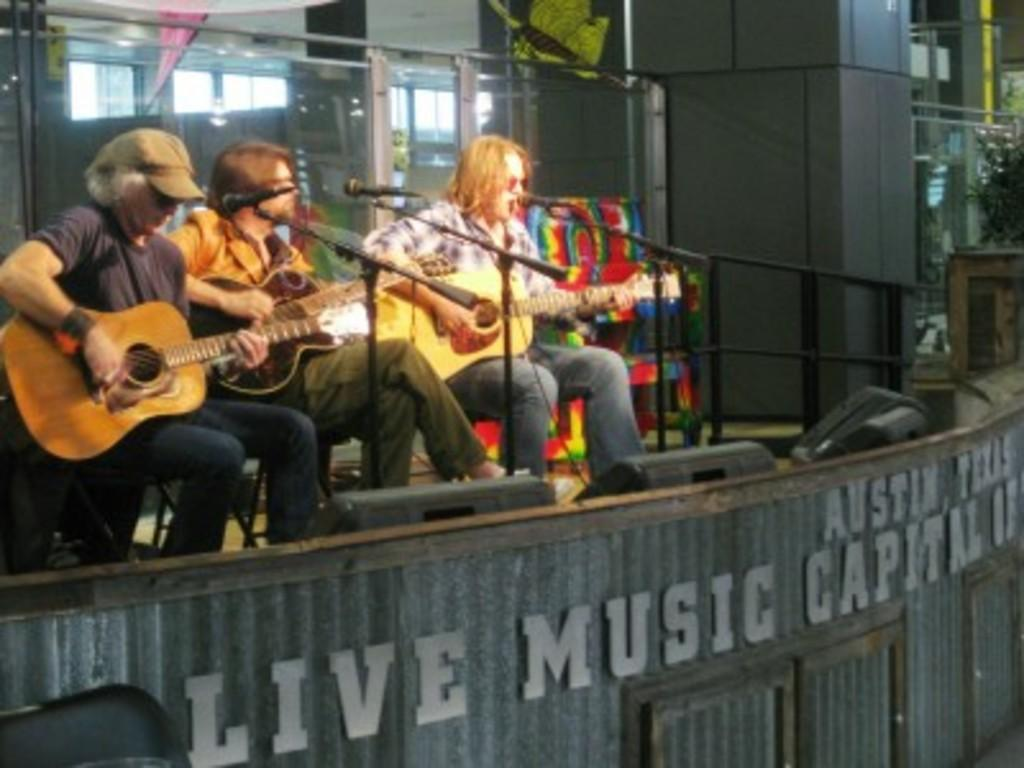How many people are in the image? There are three persons in the image. What are the persons doing in the image? The persons are sitting in chairs and playing the guitar. What can be seen in the background of the image? There is a plant, an iron rod, speakers, and grills in the background of the image. What type of pollution is visible in the image? There is no visible pollution in the image. Can you tell me the account number of the person playing the guitar in the image? There is no account number visible in the image. 